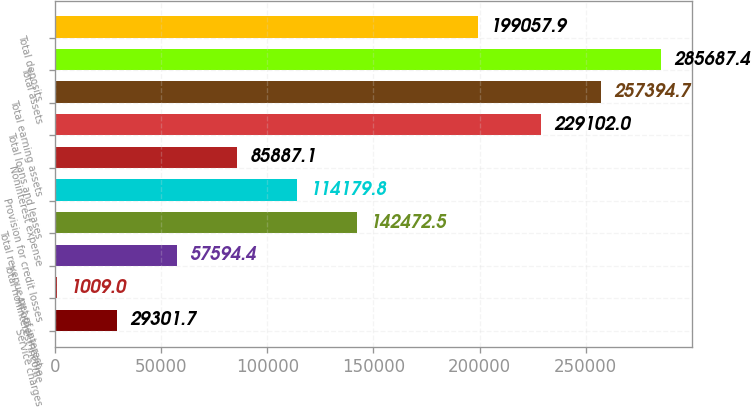<chart> <loc_0><loc_0><loc_500><loc_500><bar_chart><fcel>Service charges<fcel>All other income<fcel>Total noninterest income<fcel>Total revenue net of interest<fcel>Provision for credit losses<fcel>Noninterest expense<fcel>Total loans and leases<fcel>Total earning assets<fcel>Total assets<fcel>Total deposits<nl><fcel>29301.7<fcel>1009<fcel>57594.4<fcel>142472<fcel>114180<fcel>85887.1<fcel>229102<fcel>257395<fcel>285687<fcel>199058<nl></chart> 